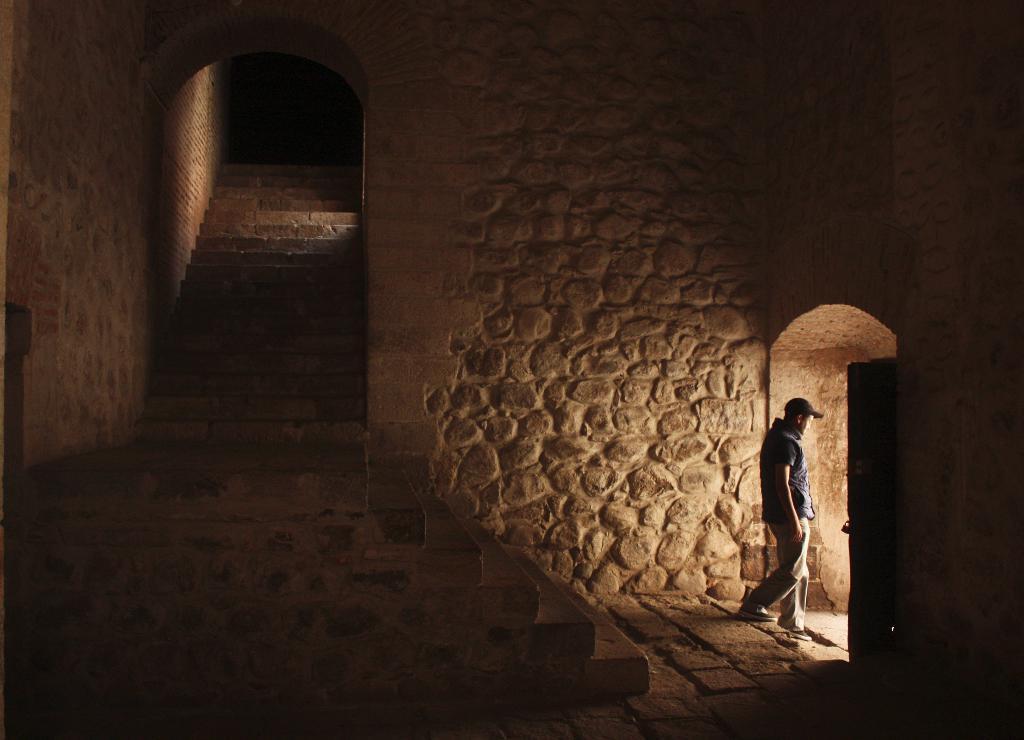Please provide a concise description of this image. On the right side of the image we can see a man walking. In the center there are stairs and there is a road. In the background there is a stone wall. 